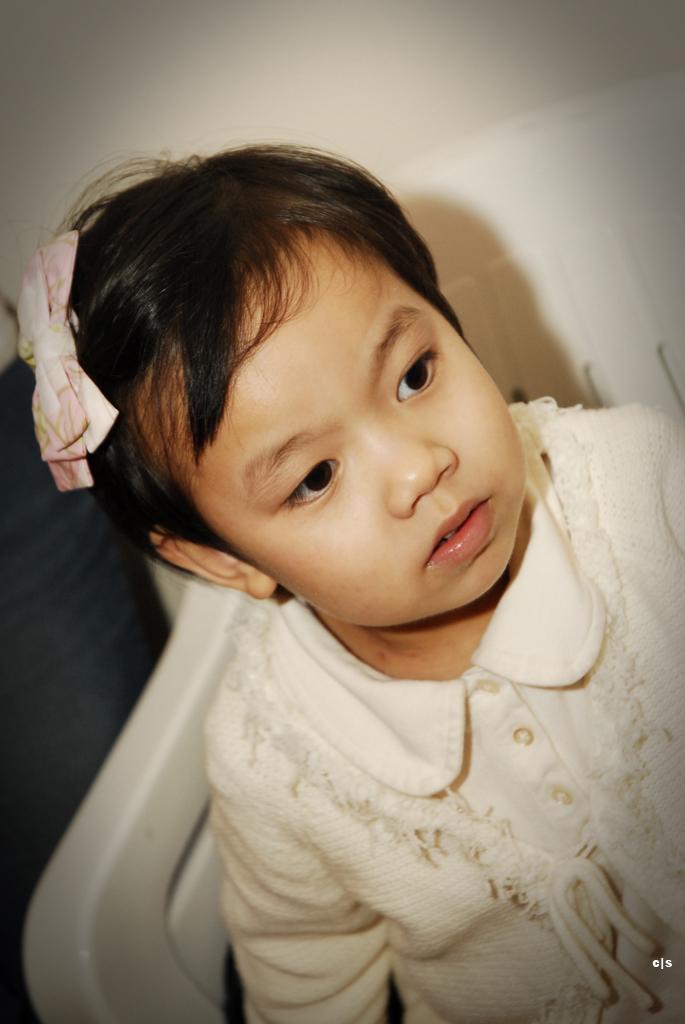How would you summarize this image in a sentence or two? In this picture, we see the girl in the white dress is sitting on the white chair. Behind her, we see a white wall. On the left side, it is black in color. 